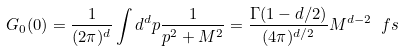<formula> <loc_0><loc_0><loc_500><loc_500>G _ { 0 } ( 0 ) = \frac { 1 } { ( 2 \pi ) ^ { d } } \int d ^ { d } p \frac { 1 } { p ^ { 2 } + M ^ { 2 } } = \frac { \Gamma ( 1 - d / 2 ) } { ( 4 \pi ) ^ { d / 2 } } M ^ { d - 2 } \ f s</formula> 